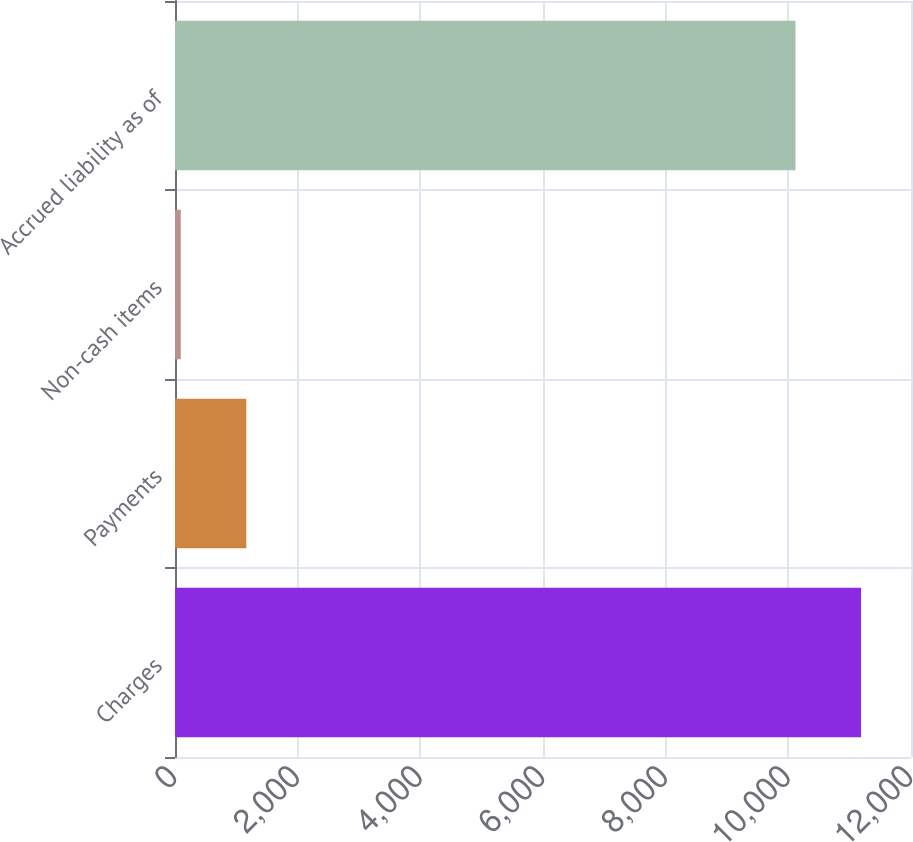Convert chart to OTSL. <chart><loc_0><loc_0><loc_500><loc_500><bar_chart><fcel>Charges<fcel>Payments<fcel>Non-cash items<fcel>Accrued liability as of<nl><fcel>11185.9<fcel>1162.9<fcel>94<fcel>10117<nl></chart> 